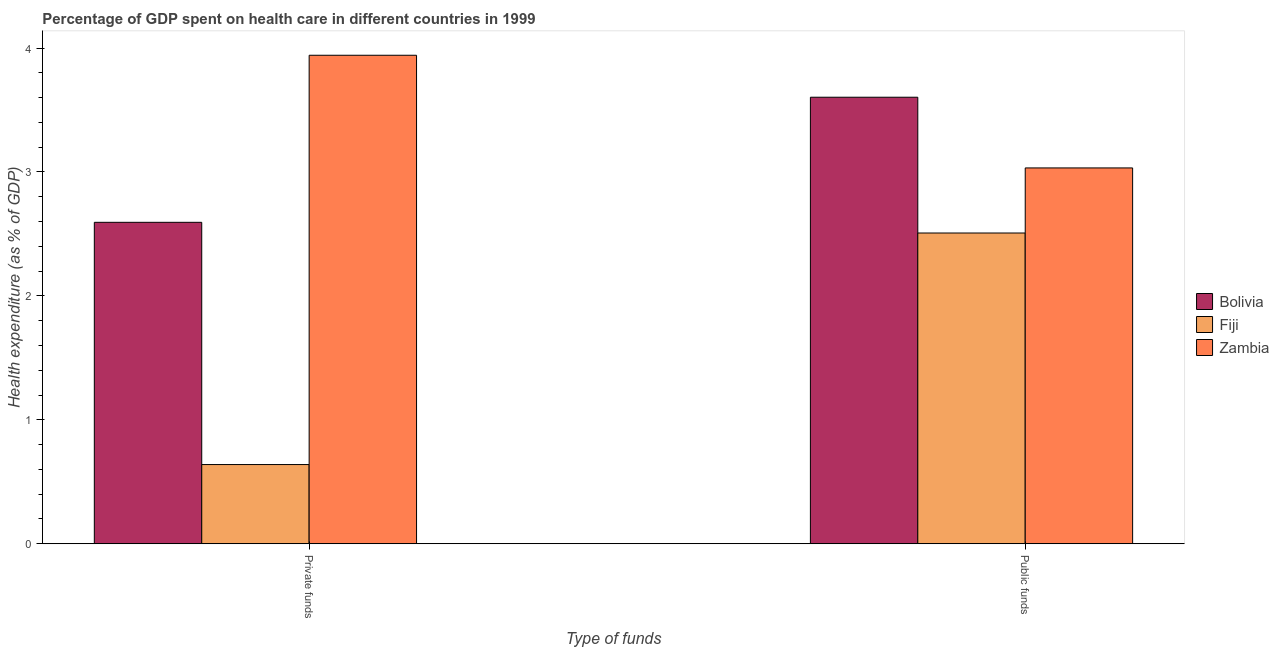How many different coloured bars are there?
Provide a succinct answer. 3. Are the number of bars per tick equal to the number of legend labels?
Your answer should be compact. Yes. Are the number of bars on each tick of the X-axis equal?
Provide a succinct answer. Yes. How many bars are there on the 1st tick from the left?
Keep it short and to the point. 3. What is the label of the 2nd group of bars from the left?
Offer a very short reply. Public funds. What is the amount of private funds spent in healthcare in Fiji?
Provide a short and direct response. 0.64. Across all countries, what is the maximum amount of private funds spent in healthcare?
Ensure brevity in your answer.  3.94. Across all countries, what is the minimum amount of private funds spent in healthcare?
Keep it short and to the point. 0.64. In which country was the amount of private funds spent in healthcare maximum?
Your response must be concise. Zambia. In which country was the amount of private funds spent in healthcare minimum?
Your answer should be very brief. Fiji. What is the total amount of private funds spent in healthcare in the graph?
Offer a terse response. 7.17. What is the difference between the amount of public funds spent in healthcare in Fiji and that in Zambia?
Your answer should be very brief. -0.53. What is the difference between the amount of public funds spent in healthcare in Fiji and the amount of private funds spent in healthcare in Zambia?
Provide a succinct answer. -1.43. What is the average amount of public funds spent in healthcare per country?
Your answer should be very brief. 3.05. What is the difference between the amount of public funds spent in healthcare and amount of private funds spent in healthcare in Zambia?
Keep it short and to the point. -0.91. In how many countries, is the amount of private funds spent in healthcare greater than 3.2 %?
Give a very brief answer. 1. What is the ratio of the amount of private funds spent in healthcare in Bolivia to that in Fiji?
Ensure brevity in your answer.  4.06. What does the 2nd bar from the left in Private funds represents?
Give a very brief answer. Fiji. What does the 2nd bar from the right in Private funds represents?
Make the answer very short. Fiji. How many bars are there?
Provide a succinct answer. 6. Are all the bars in the graph horizontal?
Your answer should be compact. No. How many countries are there in the graph?
Provide a succinct answer. 3. How many legend labels are there?
Your answer should be compact. 3. How are the legend labels stacked?
Offer a very short reply. Vertical. What is the title of the graph?
Your response must be concise. Percentage of GDP spent on health care in different countries in 1999. Does "Myanmar" appear as one of the legend labels in the graph?
Give a very brief answer. No. What is the label or title of the X-axis?
Your response must be concise. Type of funds. What is the label or title of the Y-axis?
Offer a terse response. Health expenditure (as % of GDP). What is the Health expenditure (as % of GDP) of Bolivia in Private funds?
Give a very brief answer. 2.59. What is the Health expenditure (as % of GDP) in Fiji in Private funds?
Offer a terse response. 0.64. What is the Health expenditure (as % of GDP) of Zambia in Private funds?
Your answer should be very brief. 3.94. What is the Health expenditure (as % of GDP) of Bolivia in Public funds?
Your answer should be compact. 3.6. What is the Health expenditure (as % of GDP) in Fiji in Public funds?
Offer a very short reply. 2.51. What is the Health expenditure (as % of GDP) of Zambia in Public funds?
Your answer should be compact. 3.03. Across all Type of funds, what is the maximum Health expenditure (as % of GDP) in Bolivia?
Provide a short and direct response. 3.6. Across all Type of funds, what is the maximum Health expenditure (as % of GDP) in Fiji?
Provide a short and direct response. 2.51. Across all Type of funds, what is the maximum Health expenditure (as % of GDP) in Zambia?
Ensure brevity in your answer.  3.94. Across all Type of funds, what is the minimum Health expenditure (as % of GDP) in Bolivia?
Ensure brevity in your answer.  2.59. Across all Type of funds, what is the minimum Health expenditure (as % of GDP) in Fiji?
Offer a very short reply. 0.64. Across all Type of funds, what is the minimum Health expenditure (as % of GDP) of Zambia?
Keep it short and to the point. 3.03. What is the total Health expenditure (as % of GDP) of Bolivia in the graph?
Offer a terse response. 6.2. What is the total Health expenditure (as % of GDP) in Fiji in the graph?
Make the answer very short. 3.15. What is the total Health expenditure (as % of GDP) in Zambia in the graph?
Provide a short and direct response. 6.97. What is the difference between the Health expenditure (as % of GDP) in Bolivia in Private funds and that in Public funds?
Provide a short and direct response. -1.01. What is the difference between the Health expenditure (as % of GDP) of Fiji in Private funds and that in Public funds?
Offer a terse response. -1.87. What is the difference between the Health expenditure (as % of GDP) of Zambia in Private funds and that in Public funds?
Provide a short and direct response. 0.91. What is the difference between the Health expenditure (as % of GDP) of Bolivia in Private funds and the Health expenditure (as % of GDP) of Fiji in Public funds?
Your response must be concise. 0.09. What is the difference between the Health expenditure (as % of GDP) in Bolivia in Private funds and the Health expenditure (as % of GDP) in Zambia in Public funds?
Provide a succinct answer. -0.44. What is the difference between the Health expenditure (as % of GDP) of Fiji in Private funds and the Health expenditure (as % of GDP) of Zambia in Public funds?
Offer a terse response. -2.39. What is the average Health expenditure (as % of GDP) in Bolivia per Type of funds?
Offer a very short reply. 3.1. What is the average Health expenditure (as % of GDP) of Fiji per Type of funds?
Offer a very short reply. 1.57. What is the average Health expenditure (as % of GDP) of Zambia per Type of funds?
Ensure brevity in your answer.  3.49. What is the difference between the Health expenditure (as % of GDP) of Bolivia and Health expenditure (as % of GDP) of Fiji in Private funds?
Give a very brief answer. 1.95. What is the difference between the Health expenditure (as % of GDP) of Bolivia and Health expenditure (as % of GDP) of Zambia in Private funds?
Keep it short and to the point. -1.35. What is the difference between the Health expenditure (as % of GDP) of Fiji and Health expenditure (as % of GDP) of Zambia in Private funds?
Your answer should be compact. -3.3. What is the difference between the Health expenditure (as % of GDP) of Bolivia and Health expenditure (as % of GDP) of Fiji in Public funds?
Keep it short and to the point. 1.1. What is the difference between the Health expenditure (as % of GDP) of Bolivia and Health expenditure (as % of GDP) of Zambia in Public funds?
Provide a short and direct response. 0.57. What is the difference between the Health expenditure (as % of GDP) of Fiji and Health expenditure (as % of GDP) of Zambia in Public funds?
Your answer should be very brief. -0.53. What is the ratio of the Health expenditure (as % of GDP) of Bolivia in Private funds to that in Public funds?
Your response must be concise. 0.72. What is the ratio of the Health expenditure (as % of GDP) in Fiji in Private funds to that in Public funds?
Make the answer very short. 0.25. What is the ratio of the Health expenditure (as % of GDP) of Zambia in Private funds to that in Public funds?
Give a very brief answer. 1.3. What is the difference between the highest and the second highest Health expenditure (as % of GDP) of Bolivia?
Give a very brief answer. 1.01. What is the difference between the highest and the second highest Health expenditure (as % of GDP) of Fiji?
Ensure brevity in your answer.  1.87. What is the difference between the highest and the second highest Health expenditure (as % of GDP) in Zambia?
Provide a short and direct response. 0.91. What is the difference between the highest and the lowest Health expenditure (as % of GDP) of Bolivia?
Your answer should be compact. 1.01. What is the difference between the highest and the lowest Health expenditure (as % of GDP) in Fiji?
Your answer should be very brief. 1.87. What is the difference between the highest and the lowest Health expenditure (as % of GDP) in Zambia?
Provide a short and direct response. 0.91. 